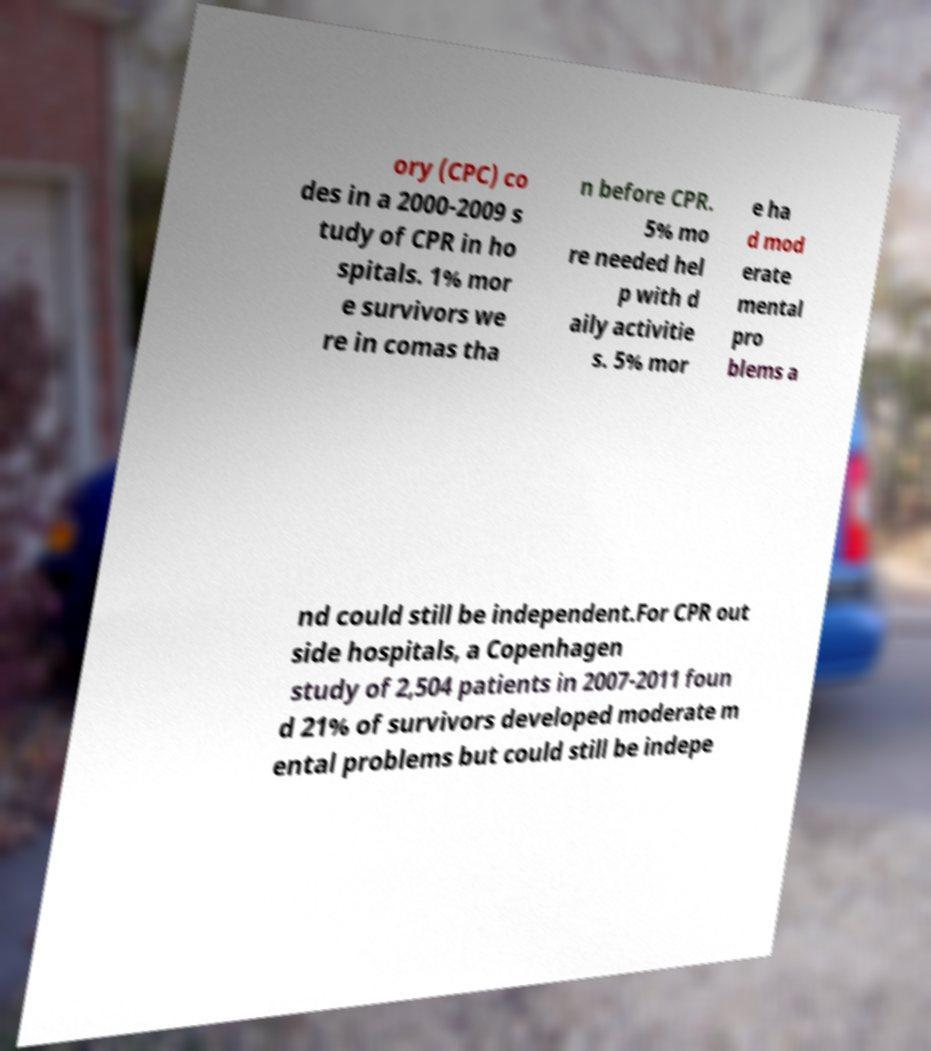For documentation purposes, I need the text within this image transcribed. Could you provide that? ory (CPC) co des in a 2000-2009 s tudy of CPR in ho spitals. 1% mor e survivors we re in comas tha n before CPR. 5% mo re needed hel p with d aily activitie s. 5% mor e ha d mod erate mental pro blems a nd could still be independent.For CPR out side hospitals, a Copenhagen study of 2,504 patients in 2007-2011 foun d 21% of survivors developed moderate m ental problems but could still be indepe 